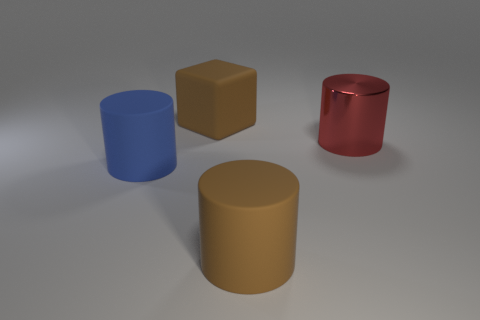There is a big cylinder in front of the blue thing; what is its color?
Provide a short and direct response. Brown. What shape is the big object that is the same color as the big matte cube?
Keep it short and to the point. Cylinder. The object that is to the left of the large cube has what shape?
Offer a terse response. Cylinder. How many brown objects are large things or cubes?
Offer a very short reply. 2. Is the blue thing made of the same material as the block?
Your answer should be compact. Yes. What number of big brown objects are to the left of the blue object?
Offer a very short reply. 0. There is a big thing that is both in front of the matte cube and behind the big blue matte thing; what is its material?
Your response must be concise. Metal. What number of cylinders are red things or big blue objects?
Your answer should be compact. 2. What is the material of the big blue object that is the same shape as the big red thing?
Offer a very short reply. Rubber. What size is the blue cylinder that is made of the same material as the brown cube?
Your answer should be very brief. Large. 